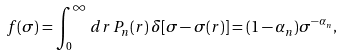Convert formula to latex. <formula><loc_0><loc_0><loc_500><loc_500>f ( \sigma ) = \int _ { 0 } ^ { \infty } \, d r \, P _ { n } ( r ) \, \delta [ \sigma - \sigma ( r ) ] = ( 1 - \alpha _ { n } ) \sigma ^ { - \alpha _ { n } } ,</formula> 